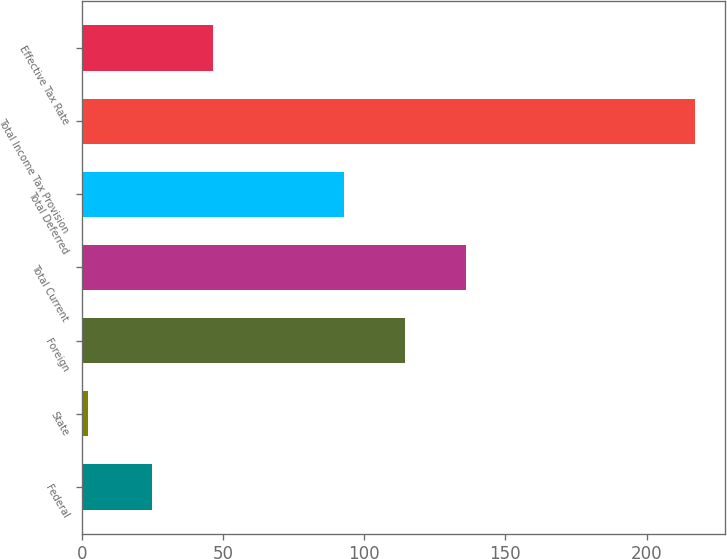<chart> <loc_0><loc_0><loc_500><loc_500><bar_chart><fcel>Federal<fcel>State<fcel>Foreign<fcel>Total Current<fcel>Total Deferred<fcel>Total Income Tax Provision<fcel>Effective Tax Rate<nl><fcel>25<fcel>2<fcel>114.5<fcel>136<fcel>93<fcel>217<fcel>46.5<nl></chart> 